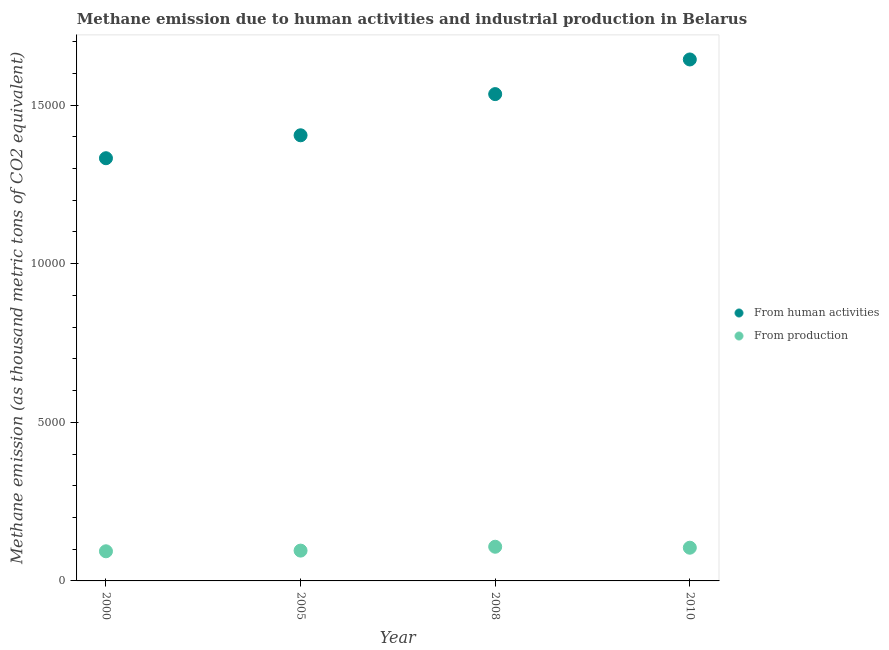How many different coloured dotlines are there?
Ensure brevity in your answer.  2. Is the number of dotlines equal to the number of legend labels?
Keep it short and to the point. Yes. What is the amount of emissions generated from industries in 2005?
Provide a succinct answer. 955.3. Across all years, what is the maximum amount of emissions from human activities?
Offer a very short reply. 1.64e+04. Across all years, what is the minimum amount of emissions from human activities?
Your response must be concise. 1.33e+04. What is the total amount of emissions from human activities in the graph?
Provide a short and direct response. 5.92e+04. What is the difference between the amount of emissions from human activities in 2000 and that in 2005?
Provide a short and direct response. -723. What is the difference between the amount of emissions generated from industries in 2000 and the amount of emissions from human activities in 2005?
Provide a short and direct response. -1.31e+04. What is the average amount of emissions from human activities per year?
Your response must be concise. 1.48e+04. In the year 2000, what is the difference between the amount of emissions from human activities and amount of emissions generated from industries?
Provide a succinct answer. 1.24e+04. What is the ratio of the amount of emissions generated from industries in 2005 to that in 2010?
Your answer should be compact. 0.91. What is the difference between the highest and the second highest amount of emissions generated from industries?
Provide a succinct answer. 30.5. What is the difference between the highest and the lowest amount of emissions generated from industries?
Provide a short and direct response. 143. In how many years, is the amount of emissions generated from industries greater than the average amount of emissions generated from industries taken over all years?
Your response must be concise. 2. Does the amount of emissions generated from industries monotonically increase over the years?
Provide a succinct answer. No. Is the amount of emissions from human activities strictly greater than the amount of emissions generated from industries over the years?
Offer a terse response. Yes. Does the graph contain any zero values?
Provide a succinct answer. No. Does the graph contain grids?
Offer a terse response. No. Where does the legend appear in the graph?
Your answer should be compact. Center right. How many legend labels are there?
Ensure brevity in your answer.  2. How are the legend labels stacked?
Make the answer very short. Vertical. What is the title of the graph?
Your answer should be very brief. Methane emission due to human activities and industrial production in Belarus. Does "Tetanus" appear as one of the legend labels in the graph?
Your answer should be compact. No. What is the label or title of the Y-axis?
Offer a very short reply. Methane emission (as thousand metric tons of CO2 equivalent). What is the Methane emission (as thousand metric tons of CO2 equivalent) of From human activities in 2000?
Give a very brief answer. 1.33e+04. What is the Methane emission (as thousand metric tons of CO2 equivalent) in From production in 2000?
Provide a short and direct response. 934.2. What is the Methane emission (as thousand metric tons of CO2 equivalent) of From human activities in 2005?
Provide a succinct answer. 1.40e+04. What is the Methane emission (as thousand metric tons of CO2 equivalent) in From production in 2005?
Ensure brevity in your answer.  955.3. What is the Methane emission (as thousand metric tons of CO2 equivalent) in From human activities in 2008?
Provide a succinct answer. 1.53e+04. What is the Methane emission (as thousand metric tons of CO2 equivalent) in From production in 2008?
Your response must be concise. 1077.2. What is the Methane emission (as thousand metric tons of CO2 equivalent) of From human activities in 2010?
Ensure brevity in your answer.  1.64e+04. What is the Methane emission (as thousand metric tons of CO2 equivalent) in From production in 2010?
Provide a succinct answer. 1046.7. Across all years, what is the maximum Methane emission (as thousand metric tons of CO2 equivalent) of From human activities?
Your response must be concise. 1.64e+04. Across all years, what is the maximum Methane emission (as thousand metric tons of CO2 equivalent) of From production?
Offer a terse response. 1077.2. Across all years, what is the minimum Methane emission (as thousand metric tons of CO2 equivalent) of From human activities?
Your answer should be compact. 1.33e+04. Across all years, what is the minimum Methane emission (as thousand metric tons of CO2 equivalent) in From production?
Offer a terse response. 934.2. What is the total Methane emission (as thousand metric tons of CO2 equivalent) of From human activities in the graph?
Your response must be concise. 5.92e+04. What is the total Methane emission (as thousand metric tons of CO2 equivalent) in From production in the graph?
Give a very brief answer. 4013.4. What is the difference between the Methane emission (as thousand metric tons of CO2 equivalent) of From human activities in 2000 and that in 2005?
Your response must be concise. -723. What is the difference between the Methane emission (as thousand metric tons of CO2 equivalent) in From production in 2000 and that in 2005?
Offer a terse response. -21.1. What is the difference between the Methane emission (as thousand metric tons of CO2 equivalent) in From human activities in 2000 and that in 2008?
Provide a short and direct response. -2020.8. What is the difference between the Methane emission (as thousand metric tons of CO2 equivalent) in From production in 2000 and that in 2008?
Ensure brevity in your answer.  -143. What is the difference between the Methane emission (as thousand metric tons of CO2 equivalent) of From human activities in 2000 and that in 2010?
Make the answer very short. -3112.7. What is the difference between the Methane emission (as thousand metric tons of CO2 equivalent) of From production in 2000 and that in 2010?
Offer a terse response. -112.5. What is the difference between the Methane emission (as thousand metric tons of CO2 equivalent) in From human activities in 2005 and that in 2008?
Offer a terse response. -1297.8. What is the difference between the Methane emission (as thousand metric tons of CO2 equivalent) in From production in 2005 and that in 2008?
Your response must be concise. -121.9. What is the difference between the Methane emission (as thousand metric tons of CO2 equivalent) of From human activities in 2005 and that in 2010?
Provide a succinct answer. -2389.7. What is the difference between the Methane emission (as thousand metric tons of CO2 equivalent) in From production in 2005 and that in 2010?
Offer a terse response. -91.4. What is the difference between the Methane emission (as thousand metric tons of CO2 equivalent) in From human activities in 2008 and that in 2010?
Your answer should be compact. -1091.9. What is the difference between the Methane emission (as thousand metric tons of CO2 equivalent) of From production in 2008 and that in 2010?
Provide a short and direct response. 30.5. What is the difference between the Methane emission (as thousand metric tons of CO2 equivalent) in From human activities in 2000 and the Methane emission (as thousand metric tons of CO2 equivalent) in From production in 2005?
Your answer should be very brief. 1.24e+04. What is the difference between the Methane emission (as thousand metric tons of CO2 equivalent) of From human activities in 2000 and the Methane emission (as thousand metric tons of CO2 equivalent) of From production in 2008?
Your answer should be very brief. 1.22e+04. What is the difference between the Methane emission (as thousand metric tons of CO2 equivalent) of From human activities in 2000 and the Methane emission (as thousand metric tons of CO2 equivalent) of From production in 2010?
Make the answer very short. 1.23e+04. What is the difference between the Methane emission (as thousand metric tons of CO2 equivalent) in From human activities in 2005 and the Methane emission (as thousand metric tons of CO2 equivalent) in From production in 2008?
Your answer should be compact. 1.30e+04. What is the difference between the Methane emission (as thousand metric tons of CO2 equivalent) in From human activities in 2005 and the Methane emission (as thousand metric tons of CO2 equivalent) in From production in 2010?
Make the answer very short. 1.30e+04. What is the difference between the Methane emission (as thousand metric tons of CO2 equivalent) in From human activities in 2008 and the Methane emission (as thousand metric tons of CO2 equivalent) in From production in 2010?
Provide a short and direct response. 1.43e+04. What is the average Methane emission (as thousand metric tons of CO2 equivalent) of From human activities per year?
Ensure brevity in your answer.  1.48e+04. What is the average Methane emission (as thousand metric tons of CO2 equivalent) in From production per year?
Ensure brevity in your answer.  1003.35. In the year 2000, what is the difference between the Methane emission (as thousand metric tons of CO2 equivalent) of From human activities and Methane emission (as thousand metric tons of CO2 equivalent) of From production?
Ensure brevity in your answer.  1.24e+04. In the year 2005, what is the difference between the Methane emission (as thousand metric tons of CO2 equivalent) in From human activities and Methane emission (as thousand metric tons of CO2 equivalent) in From production?
Provide a succinct answer. 1.31e+04. In the year 2008, what is the difference between the Methane emission (as thousand metric tons of CO2 equivalent) of From human activities and Methane emission (as thousand metric tons of CO2 equivalent) of From production?
Offer a very short reply. 1.43e+04. In the year 2010, what is the difference between the Methane emission (as thousand metric tons of CO2 equivalent) in From human activities and Methane emission (as thousand metric tons of CO2 equivalent) in From production?
Keep it short and to the point. 1.54e+04. What is the ratio of the Methane emission (as thousand metric tons of CO2 equivalent) in From human activities in 2000 to that in 2005?
Give a very brief answer. 0.95. What is the ratio of the Methane emission (as thousand metric tons of CO2 equivalent) of From production in 2000 to that in 2005?
Offer a very short reply. 0.98. What is the ratio of the Methane emission (as thousand metric tons of CO2 equivalent) in From human activities in 2000 to that in 2008?
Your response must be concise. 0.87. What is the ratio of the Methane emission (as thousand metric tons of CO2 equivalent) in From production in 2000 to that in 2008?
Make the answer very short. 0.87. What is the ratio of the Methane emission (as thousand metric tons of CO2 equivalent) in From human activities in 2000 to that in 2010?
Offer a very short reply. 0.81. What is the ratio of the Methane emission (as thousand metric tons of CO2 equivalent) of From production in 2000 to that in 2010?
Your answer should be very brief. 0.89. What is the ratio of the Methane emission (as thousand metric tons of CO2 equivalent) in From human activities in 2005 to that in 2008?
Provide a short and direct response. 0.92. What is the ratio of the Methane emission (as thousand metric tons of CO2 equivalent) in From production in 2005 to that in 2008?
Offer a terse response. 0.89. What is the ratio of the Methane emission (as thousand metric tons of CO2 equivalent) in From human activities in 2005 to that in 2010?
Your answer should be compact. 0.85. What is the ratio of the Methane emission (as thousand metric tons of CO2 equivalent) of From production in 2005 to that in 2010?
Offer a terse response. 0.91. What is the ratio of the Methane emission (as thousand metric tons of CO2 equivalent) in From human activities in 2008 to that in 2010?
Your answer should be very brief. 0.93. What is the ratio of the Methane emission (as thousand metric tons of CO2 equivalent) of From production in 2008 to that in 2010?
Your answer should be compact. 1.03. What is the difference between the highest and the second highest Methane emission (as thousand metric tons of CO2 equivalent) in From human activities?
Make the answer very short. 1091.9. What is the difference between the highest and the second highest Methane emission (as thousand metric tons of CO2 equivalent) of From production?
Your response must be concise. 30.5. What is the difference between the highest and the lowest Methane emission (as thousand metric tons of CO2 equivalent) of From human activities?
Offer a terse response. 3112.7. What is the difference between the highest and the lowest Methane emission (as thousand metric tons of CO2 equivalent) of From production?
Your response must be concise. 143. 